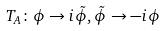<formula> <loc_0><loc_0><loc_500><loc_500>T _ { A } \colon \phi \rightarrow i \tilde { \phi } , \tilde { \phi } \rightarrow - i \phi</formula> 